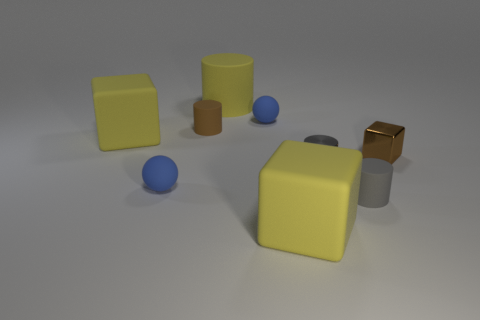Does this image seem like it's a part of a larger narrative or isolated experimentation? The image appears to be an isolated experiment or a study in 3D modeling and rendering, focusing on texture, color, and light. There is no clear indication of a narrative or storyline; the primary focus seems to be on the visual and aesthetic qualities of the geometric shapes within a simple scene. 